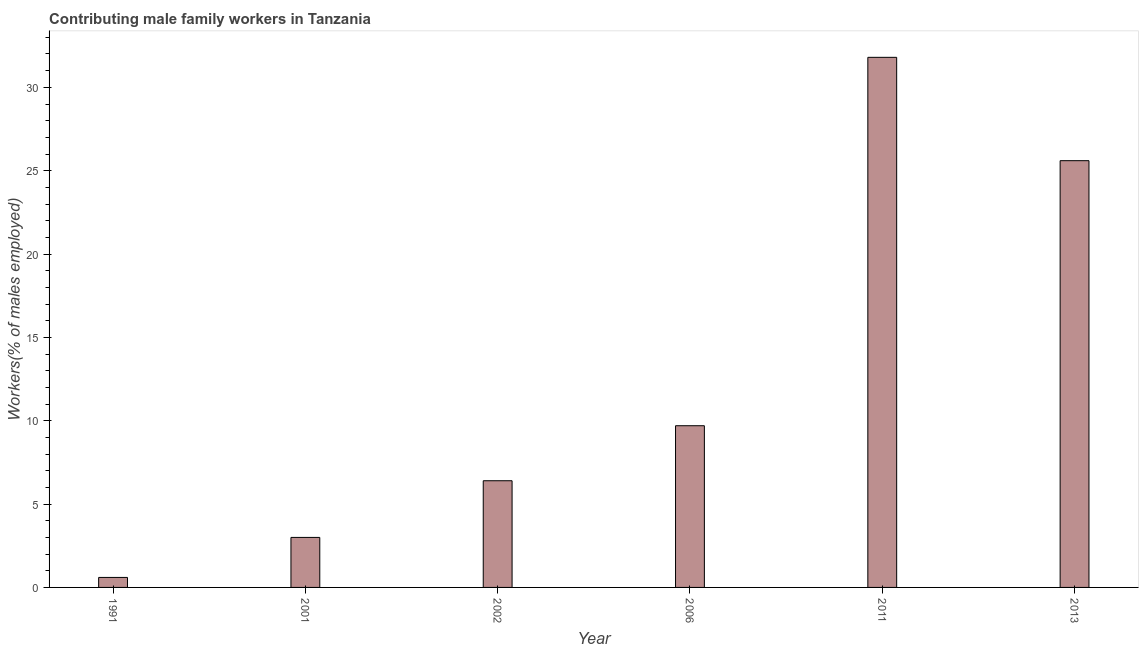What is the title of the graph?
Give a very brief answer. Contributing male family workers in Tanzania. What is the label or title of the X-axis?
Keep it short and to the point. Year. What is the label or title of the Y-axis?
Make the answer very short. Workers(% of males employed). What is the contributing male family workers in 1991?
Your response must be concise. 0.6. Across all years, what is the maximum contributing male family workers?
Your response must be concise. 31.8. Across all years, what is the minimum contributing male family workers?
Your answer should be very brief. 0.6. In which year was the contributing male family workers maximum?
Give a very brief answer. 2011. In which year was the contributing male family workers minimum?
Provide a succinct answer. 1991. What is the sum of the contributing male family workers?
Keep it short and to the point. 77.1. What is the difference between the contributing male family workers in 1991 and 2001?
Your response must be concise. -2.4. What is the average contributing male family workers per year?
Make the answer very short. 12.85. What is the median contributing male family workers?
Ensure brevity in your answer.  8.05. Do a majority of the years between 1991 and 2001 (inclusive) have contributing male family workers greater than 14 %?
Provide a short and direct response. No. What is the ratio of the contributing male family workers in 2006 to that in 2011?
Keep it short and to the point. 0.3. Is the sum of the contributing male family workers in 2001 and 2006 greater than the maximum contributing male family workers across all years?
Offer a terse response. No. What is the difference between the highest and the lowest contributing male family workers?
Provide a succinct answer. 31.2. How many bars are there?
Make the answer very short. 6. Are all the bars in the graph horizontal?
Your response must be concise. No. What is the difference between two consecutive major ticks on the Y-axis?
Provide a short and direct response. 5. Are the values on the major ticks of Y-axis written in scientific E-notation?
Keep it short and to the point. No. What is the Workers(% of males employed) of 1991?
Provide a short and direct response. 0.6. What is the Workers(% of males employed) in 2001?
Provide a succinct answer. 3. What is the Workers(% of males employed) in 2002?
Offer a terse response. 6.4. What is the Workers(% of males employed) in 2006?
Give a very brief answer. 9.7. What is the Workers(% of males employed) of 2011?
Offer a terse response. 31.8. What is the Workers(% of males employed) of 2013?
Ensure brevity in your answer.  25.6. What is the difference between the Workers(% of males employed) in 1991 and 2011?
Make the answer very short. -31.2. What is the difference between the Workers(% of males employed) in 1991 and 2013?
Offer a terse response. -25. What is the difference between the Workers(% of males employed) in 2001 and 2011?
Your response must be concise. -28.8. What is the difference between the Workers(% of males employed) in 2001 and 2013?
Make the answer very short. -22.6. What is the difference between the Workers(% of males employed) in 2002 and 2006?
Make the answer very short. -3.3. What is the difference between the Workers(% of males employed) in 2002 and 2011?
Ensure brevity in your answer.  -25.4. What is the difference between the Workers(% of males employed) in 2002 and 2013?
Keep it short and to the point. -19.2. What is the difference between the Workers(% of males employed) in 2006 and 2011?
Provide a succinct answer. -22.1. What is the difference between the Workers(% of males employed) in 2006 and 2013?
Provide a short and direct response. -15.9. What is the difference between the Workers(% of males employed) in 2011 and 2013?
Your answer should be compact. 6.2. What is the ratio of the Workers(% of males employed) in 1991 to that in 2002?
Keep it short and to the point. 0.09. What is the ratio of the Workers(% of males employed) in 1991 to that in 2006?
Offer a very short reply. 0.06. What is the ratio of the Workers(% of males employed) in 1991 to that in 2011?
Ensure brevity in your answer.  0.02. What is the ratio of the Workers(% of males employed) in 1991 to that in 2013?
Provide a succinct answer. 0.02. What is the ratio of the Workers(% of males employed) in 2001 to that in 2002?
Keep it short and to the point. 0.47. What is the ratio of the Workers(% of males employed) in 2001 to that in 2006?
Give a very brief answer. 0.31. What is the ratio of the Workers(% of males employed) in 2001 to that in 2011?
Your response must be concise. 0.09. What is the ratio of the Workers(% of males employed) in 2001 to that in 2013?
Provide a short and direct response. 0.12. What is the ratio of the Workers(% of males employed) in 2002 to that in 2006?
Ensure brevity in your answer.  0.66. What is the ratio of the Workers(% of males employed) in 2002 to that in 2011?
Your answer should be very brief. 0.2. What is the ratio of the Workers(% of males employed) in 2002 to that in 2013?
Provide a succinct answer. 0.25. What is the ratio of the Workers(% of males employed) in 2006 to that in 2011?
Give a very brief answer. 0.3. What is the ratio of the Workers(% of males employed) in 2006 to that in 2013?
Keep it short and to the point. 0.38. What is the ratio of the Workers(% of males employed) in 2011 to that in 2013?
Your answer should be very brief. 1.24. 